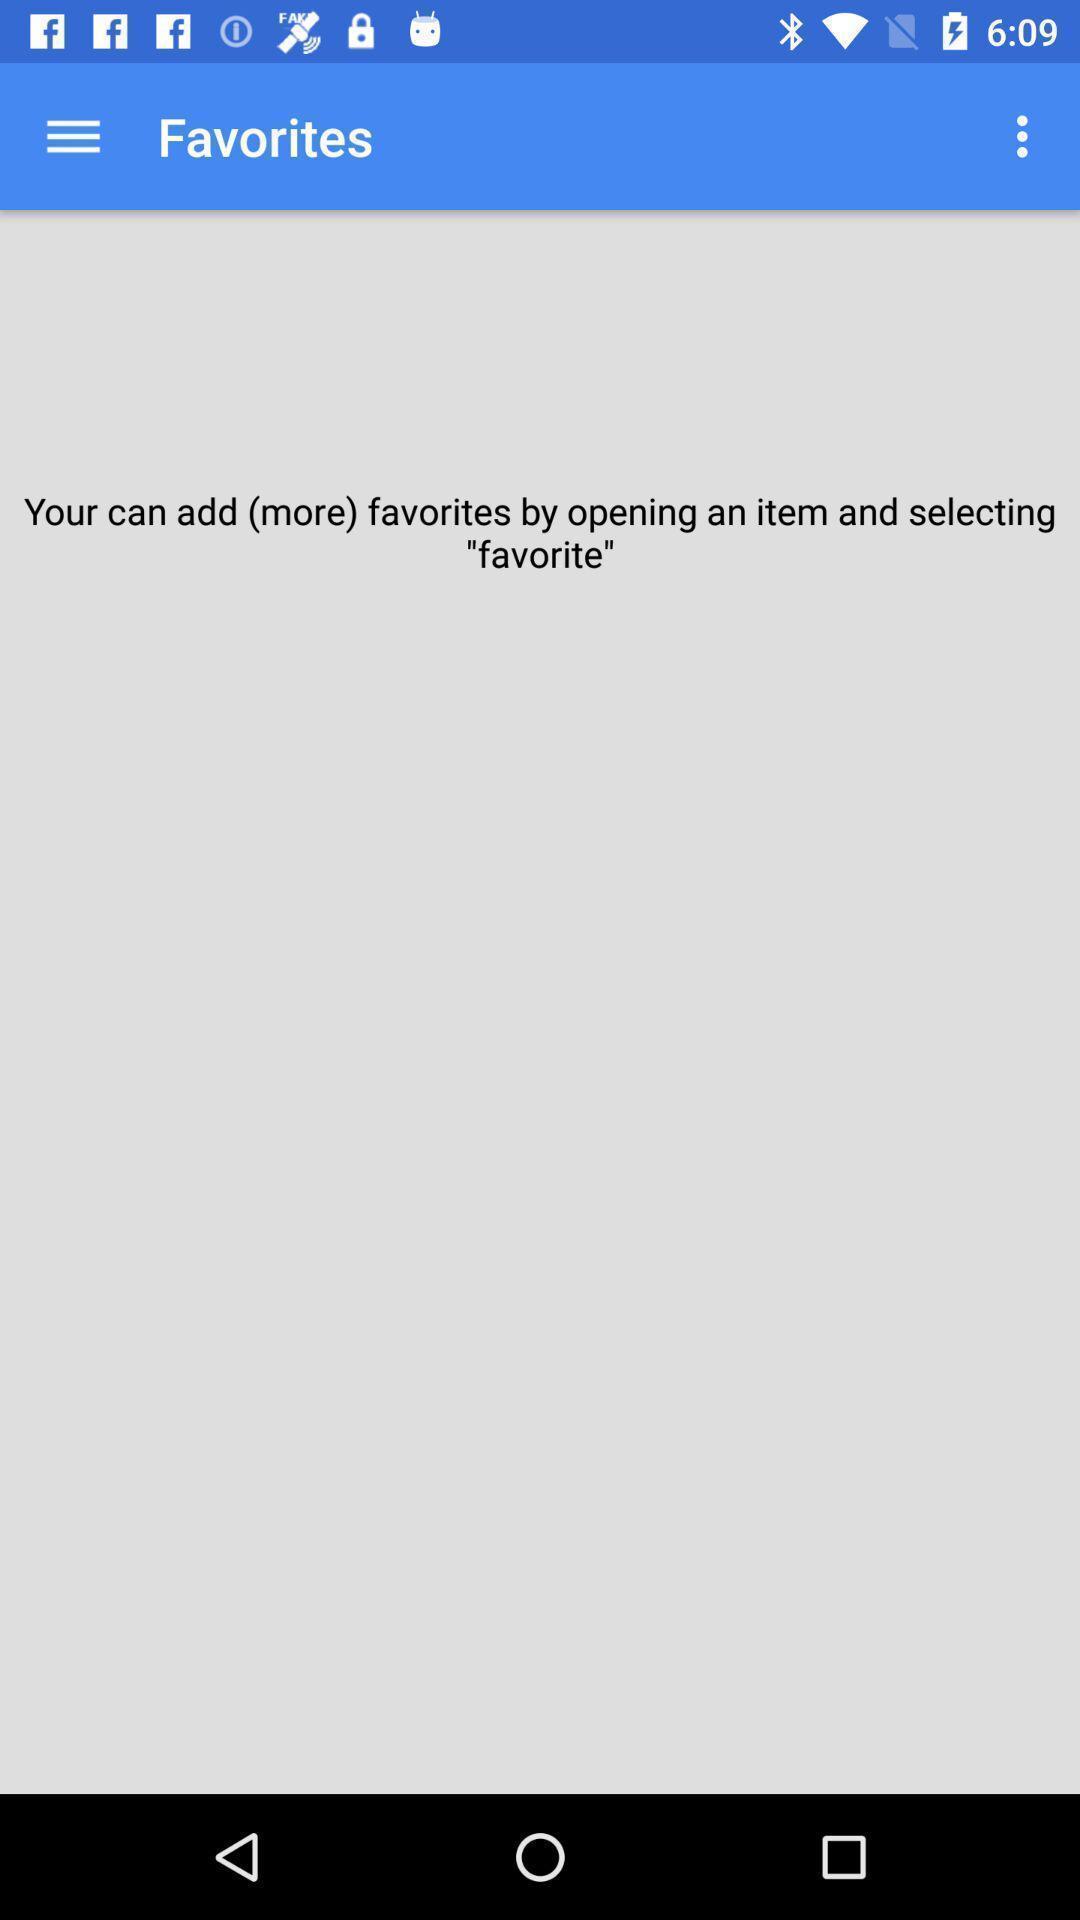Tell me about the visual elements in this screen capture. Screen displaying favorites page. 